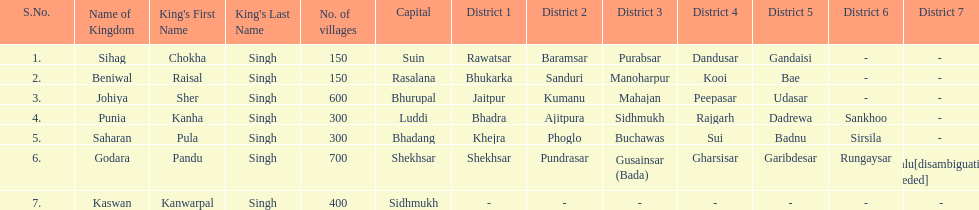How many kingdoms are listed? 7. 